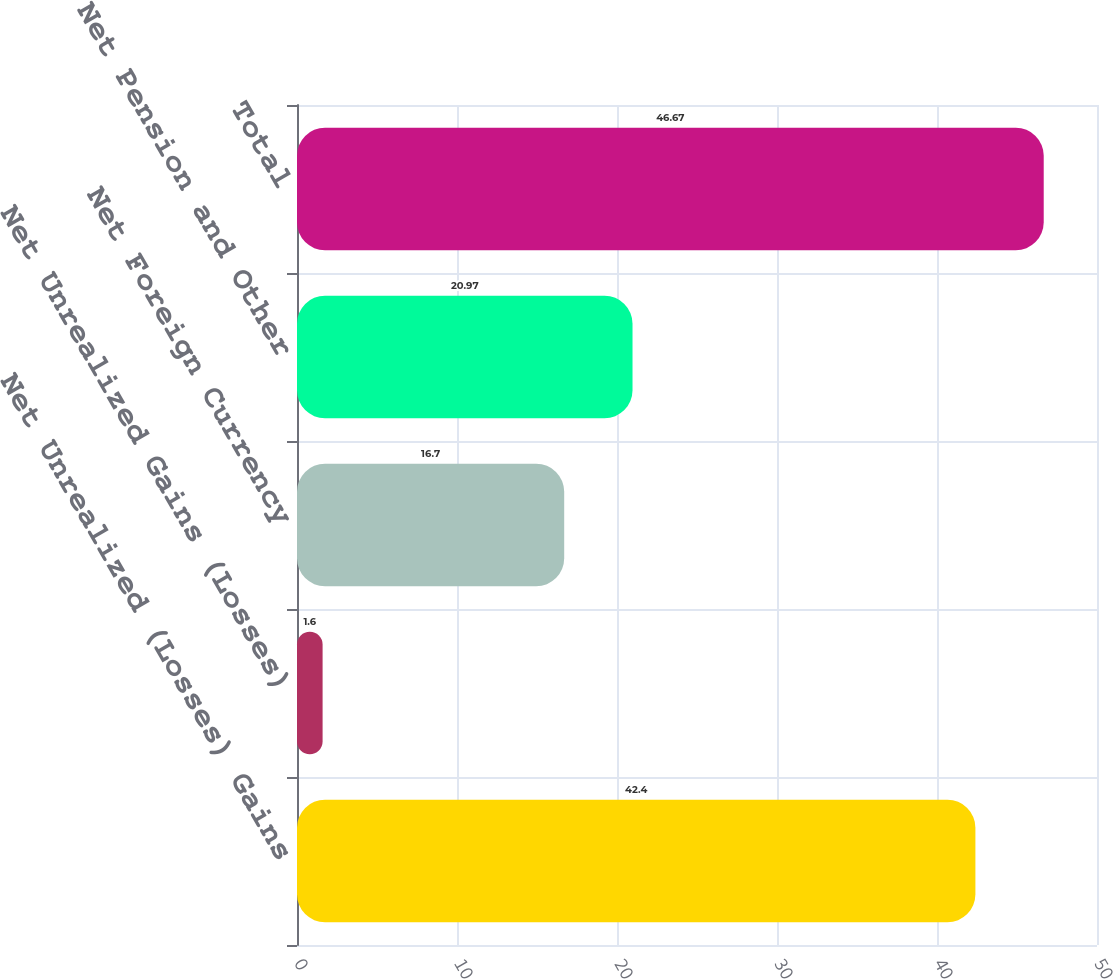<chart> <loc_0><loc_0><loc_500><loc_500><bar_chart><fcel>Net Unrealized (Losses) Gains<fcel>Net Unrealized Gains (Losses)<fcel>Net Foreign Currency<fcel>Net Pension and Other<fcel>Total<nl><fcel>42.4<fcel>1.6<fcel>16.7<fcel>20.97<fcel>46.67<nl></chart> 